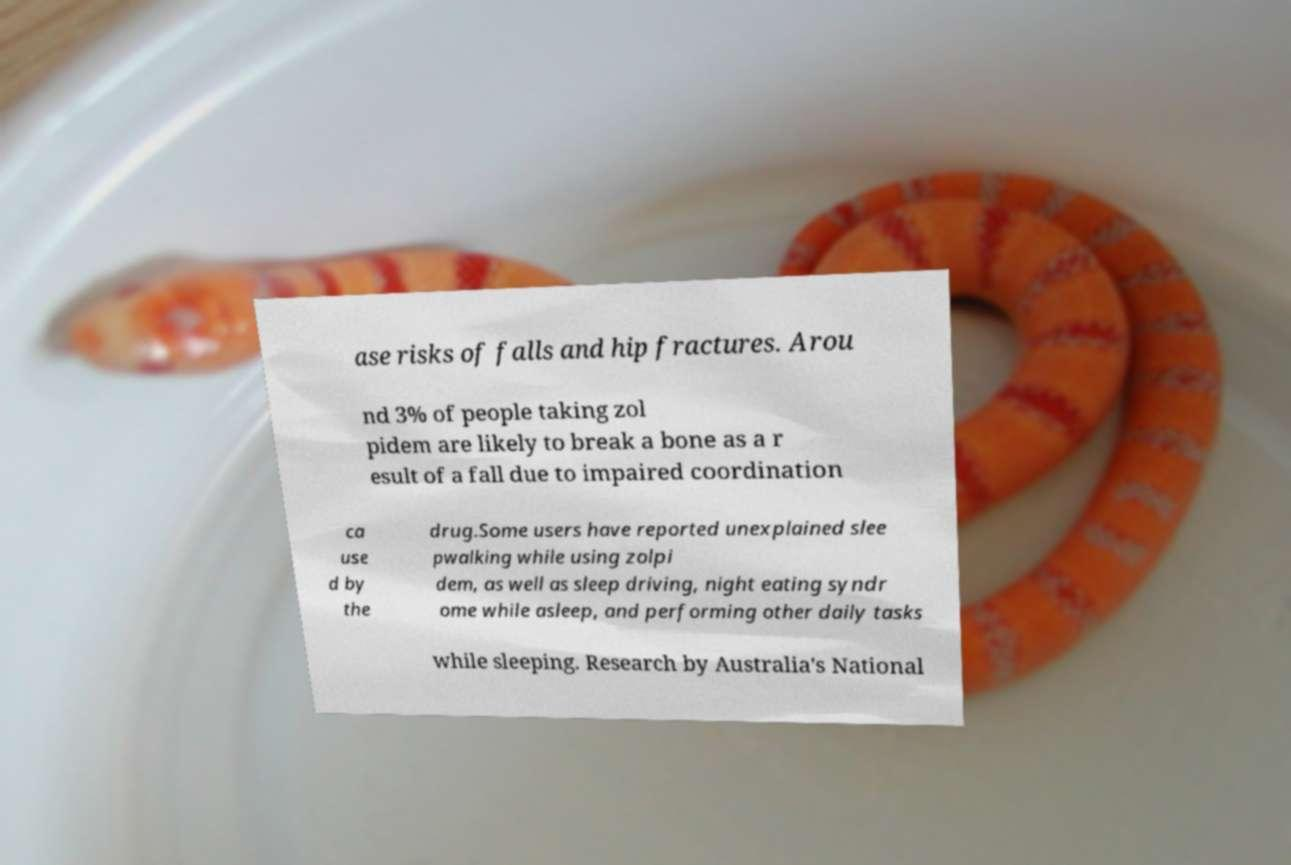For documentation purposes, I need the text within this image transcribed. Could you provide that? ase risks of falls and hip fractures. Arou nd 3% of people taking zol pidem are likely to break a bone as a r esult of a fall due to impaired coordination ca use d by the drug.Some users have reported unexplained slee pwalking while using zolpi dem, as well as sleep driving, night eating syndr ome while asleep, and performing other daily tasks while sleeping. Research by Australia's National 